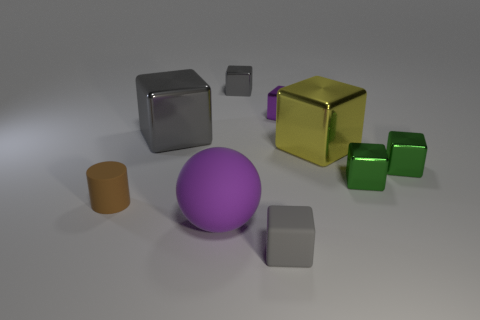How many gray cubes must be subtracted to get 1 gray cubes? 2 Subtract all purple balls. How many gray cubes are left? 3 Subtract 4 cubes. How many cubes are left? 3 Subtract all gray shiny blocks. How many blocks are left? 5 Subtract all yellow blocks. How many blocks are left? 6 Subtract all blue cubes. Subtract all red balls. How many cubes are left? 7 Subtract all cubes. How many objects are left? 2 Add 7 gray matte things. How many gray matte things exist? 8 Subtract 0 green cylinders. How many objects are left? 9 Subtract all gray cubes. Subtract all green shiny blocks. How many objects are left? 4 